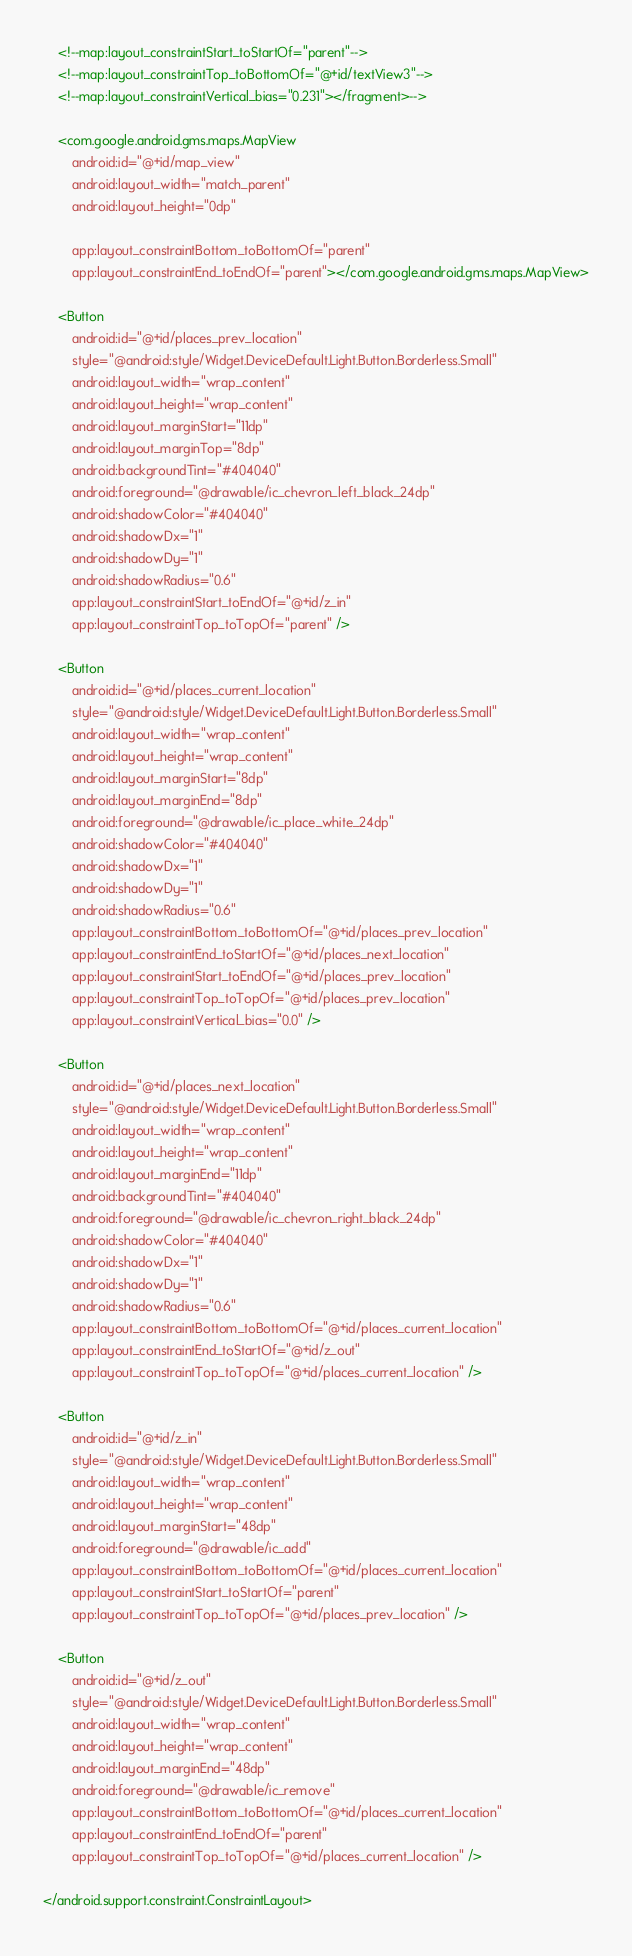Convert code to text. <code><loc_0><loc_0><loc_500><loc_500><_XML_>    <!--map:layout_constraintStart_toStartOf="parent"-->
    <!--map:layout_constraintTop_toBottomOf="@+id/textView3"-->
    <!--map:layout_constraintVertical_bias="0.231"></fragment>-->

    <com.google.android.gms.maps.MapView
        android:id="@+id/map_view"
        android:layout_width="match_parent"
        android:layout_height="0dp"

        app:layout_constraintBottom_toBottomOf="parent"
        app:layout_constraintEnd_toEndOf="parent"></com.google.android.gms.maps.MapView>

    <Button
        android:id="@+id/places_prev_location"
        style="@android:style/Widget.DeviceDefault.Light.Button.Borderless.Small"
        android:layout_width="wrap_content"
        android:layout_height="wrap_content"
        android:layout_marginStart="11dp"
        android:layout_marginTop="8dp"
        android:backgroundTint="#404040"
        android:foreground="@drawable/ic_chevron_left_black_24dp"
        android:shadowColor="#404040"
        android:shadowDx="1"
        android:shadowDy="1"
        android:shadowRadius="0.6"
        app:layout_constraintStart_toEndOf="@+id/z_in"
        app:layout_constraintTop_toTopOf="parent" />

    <Button
        android:id="@+id/places_current_location"
        style="@android:style/Widget.DeviceDefault.Light.Button.Borderless.Small"
        android:layout_width="wrap_content"
        android:layout_height="wrap_content"
        android:layout_marginStart="8dp"
        android:layout_marginEnd="8dp"
        android:foreground="@drawable/ic_place_white_24dp"
        android:shadowColor="#404040"
        android:shadowDx="1"
        android:shadowDy="1"
        android:shadowRadius="0.6"
        app:layout_constraintBottom_toBottomOf="@+id/places_prev_location"
        app:layout_constraintEnd_toStartOf="@+id/places_next_location"
        app:layout_constraintStart_toEndOf="@+id/places_prev_location"
        app:layout_constraintTop_toTopOf="@+id/places_prev_location"
        app:layout_constraintVertical_bias="0.0" />

    <Button
        android:id="@+id/places_next_location"
        style="@android:style/Widget.DeviceDefault.Light.Button.Borderless.Small"
        android:layout_width="wrap_content"
        android:layout_height="wrap_content"
        android:layout_marginEnd="11dp"
        android:backgroundTint="#404040"
        android:foreground="@drawable/ic_chevron_right_black_24dp"
        android:shadowColor="#404040"
        android:shadowDx="1"
        android:shadowDy="1"
        android:shadowRadius="0.6"
        app:layout_constraintBottom_toBottomOf="@+id/places_current_location"
        app:layout_constraintEnd_toStartOf="@+id/z_out"
        app:layout_constraintTop_toTopOf="@+id/places_current_location" />

    <Button
        android:id="@+id/z_in"
        style="@android:style/Widget.DeviceDefault.Light.Button.Borderless.Small"
        android:layout_width="wrap_content"
        android:layout_height="wrap_content"
        android:layout_marginStart="48dp"
        android:foreground="@drawable/ic_add"
        app:layout_constraintBottom_toBottomOf="@+id/places_current_location"
        app:layout_constraintStart_toStartOf="parent"
        app:layout_constraintTop_toTopOf="@+id/places_prev_location" />

    <Button
        android:id="@+id/z_out"
        style="@android:style/Widget.DeviceDefault.Light.Button.Borderless.Small"
        android:layout_width="wrap_content"
        android:layout_height="wrap_content"
        android:layout_marginEnd="48dp"
        android:foreground="@drawable/ic_remove"
        app:layout_constraintBottom_toBottomOf="@+id/places_current_location"
        app:layout_constraintEnd_toEndOf="parent"
        app:layout_constraintTop_toTopOf="@+id/places_current_location" />

</android.support.constraint.ConstraintLayout></code> 